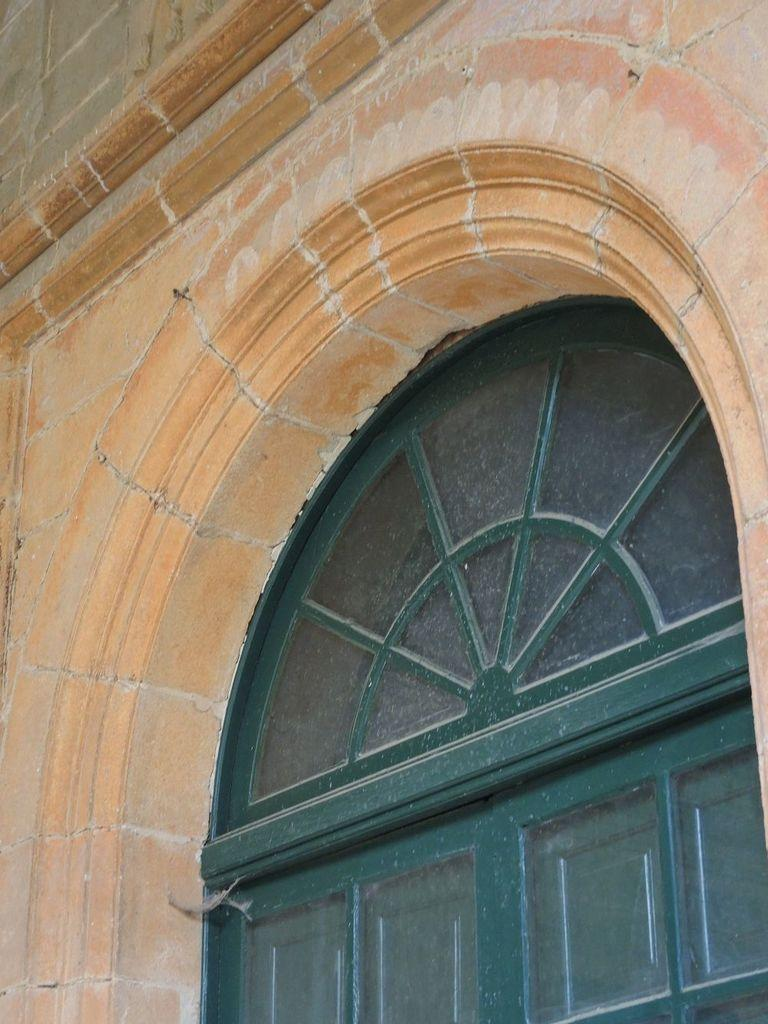What is visible in the image that allows light to enter a room? There is a window in the image that allows light to enter a room. What is another architectural feature visible in the image? There is a wall in the image. What type of fuel is required for the window to function in the image? There is no fuel required for the window to function in the image; it is a passive feature that allows light to enter a room. What shape is the transport vehicle in the image? There is no transport vehicle present in the image. 